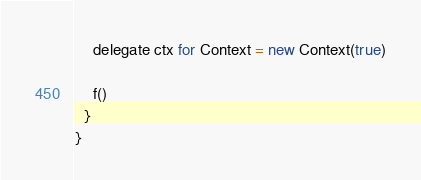Convert code to text. <code><loc_0><loc_0><loc_500><loc_500><_Scala_>    delegate ctx for Context = new Context(true)

    f()
  }
}</code> 